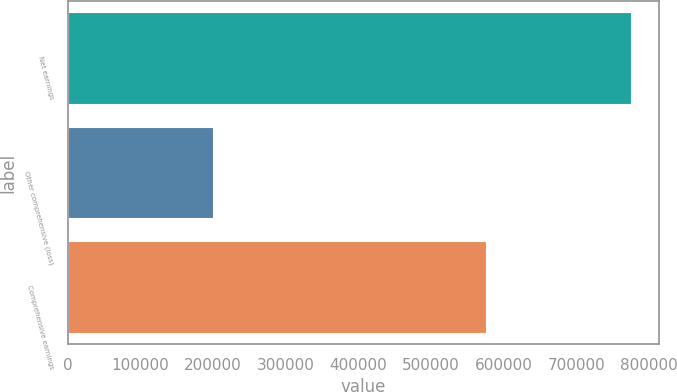<chart> <loc_0><loc_0><loc_500><loc_500><bar_chart><fcel>Net earnings<fcel>Other comprehensive (loss)<fcel>Comprehensive earnings<nl><fcel>775235<fcel>199959<fcel>575276<nl></chart> 